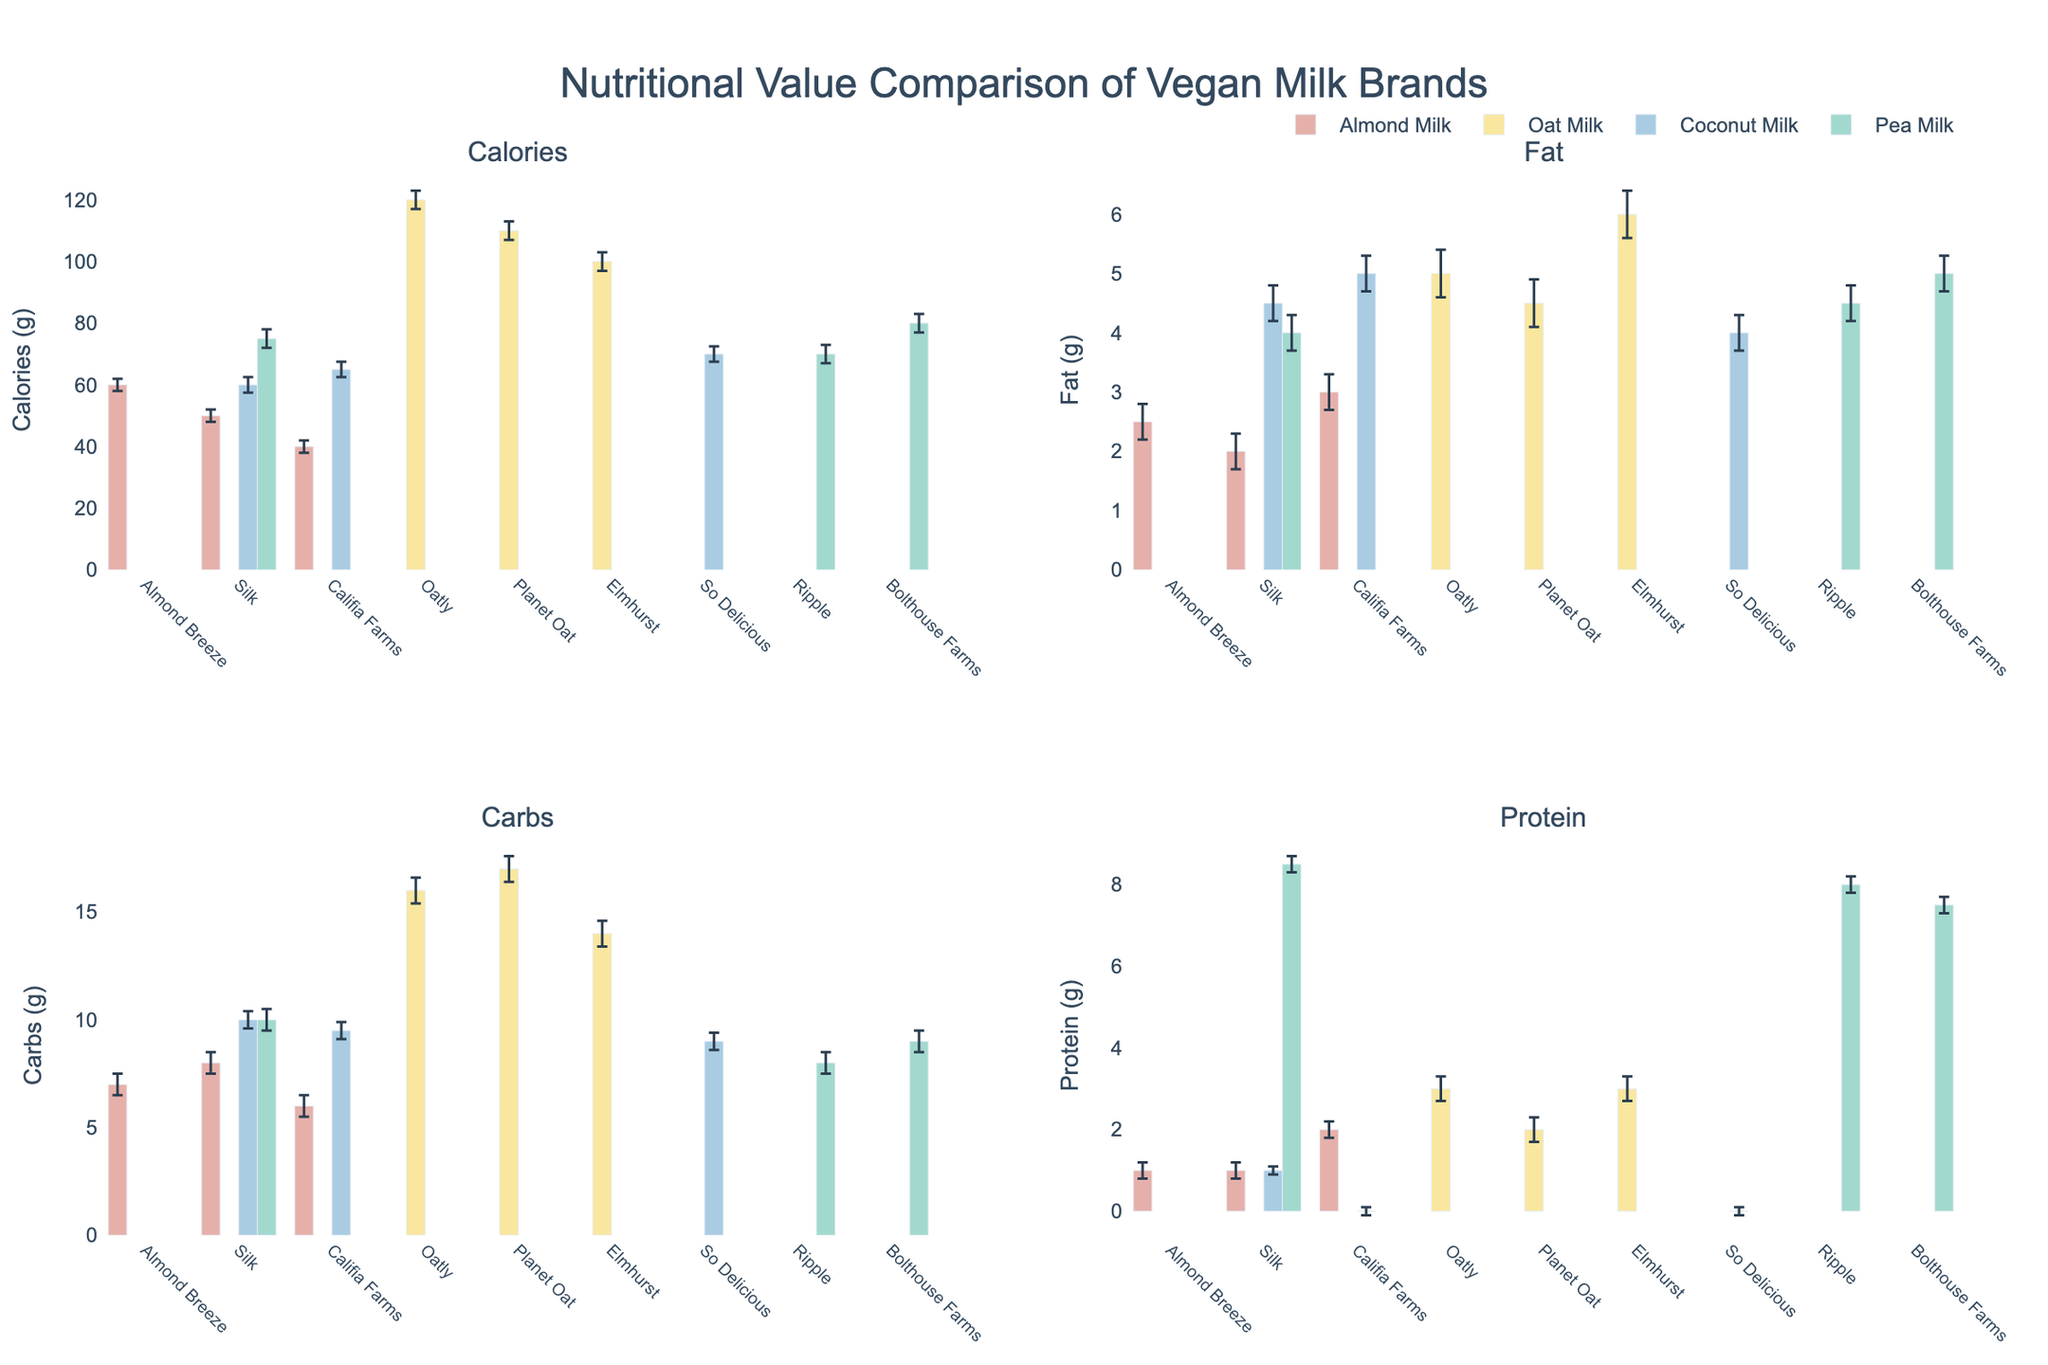What is the title of the figure? The title is displayed at the top, centered, and reads "Nutritional Value Comparison of Vegan Milk Brands".
Answer: Nutritional Value Comparison of Vegan Milk Brands Which brand of Oat Milk has the highest amount of fat? Observe the fat content bars within the Oat Milk category. Elmhurst Oat Milk has the tallest bar, indicating the highest amount of fat.
Answer: Elmhurst What is the mean number of calories in Almond Milk? The mean calorie values for Almond Milk are given as 59.
Answer: 59 Which type of milk shows the largest standard error for protein content? Look at the error bars for protein content across all milk types. Oat Milk has the largest error bars for protein.
Answer: Oat Milk Compare the average carb content of Pea Milk to that of Coconut Milk. Which one is higher and by how much? The mean carb content for Pea Milk is given as 9.1, while for Coconut Milk it is 9.5. Subtracting these values shows that Coconut Milk's average carb content is higher by 0.4 grams.
Answer: Coconut Milk by 0.4 grams What is the mean protein content of Pea Milk? The mean protein content for each milk type is listed in the data. For Pea Milk, the mean protein content is given as 7.9.
Answer: 7.9 Which brand has the highest calorie content among the almond milk brands? For Almond Milk, compare the calorie values for Almond Breeze, Silk, and Califia Farms. Almond Breeze has the highest calorie content at 60 calories.
Answer: Almond Breeze How do the average fat contents of Oat Milk and Coconut Milk compare? The data lists the mean fat content of Oat Milk as 5.2 and Coconut Milk as 4.5. Oat Milk has a higher fat content.
Answer: Oat Milk is higher Which brand of Coconut Milk has the minimum number of protein grams and what is that value? For Coconut Milk, check the protein content of So Delicious, Silk, and Califia Farms. So Delicious and Califia Farms both have 0 grams of protein.
Answer: So Delicious and Califia Farms, 0 grams For which type of milk is the difference between the highest and lowest carb content the greatest? Check the range of carb content for each type. Oat Milk ranges from 14 to 17 (3), Pea Milk from 8 to 10 (2), Almond Milk from 6 to 8 (2), and Coconut Milk from 9 to 10 (1). Oat Milk has the largest range, thus the greatest difference.
Answer: Oat Milk 